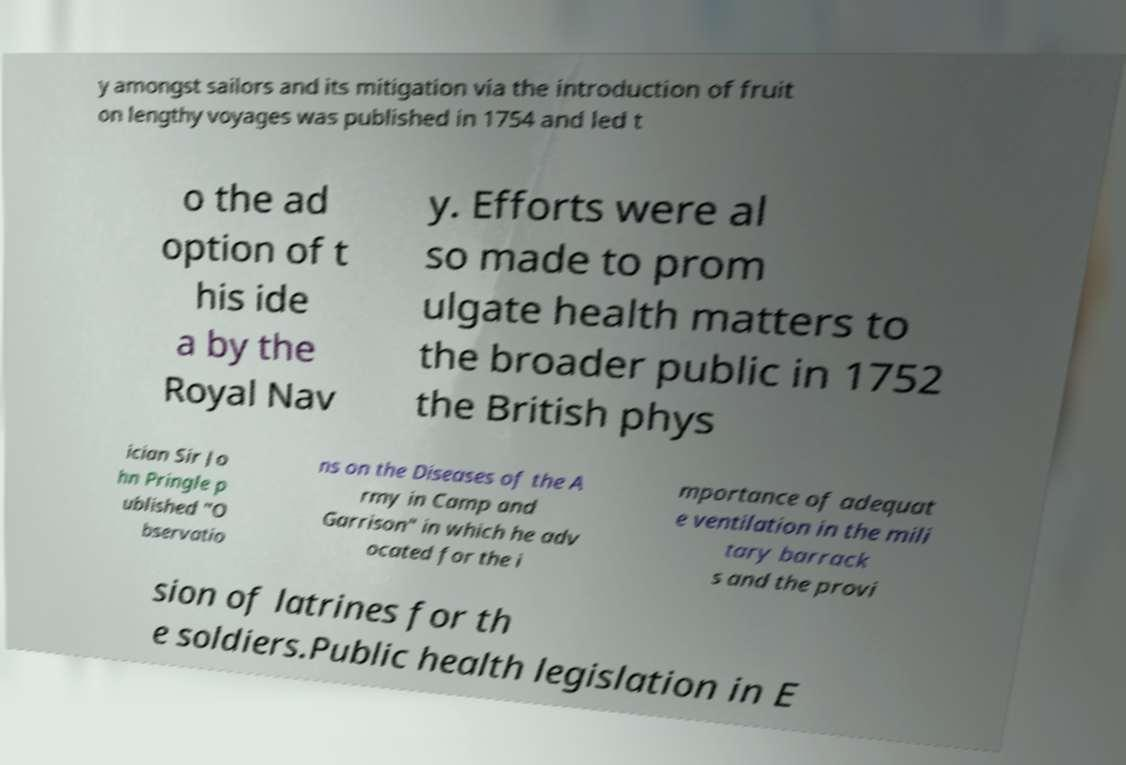Could you extract and type out the text from this image? y amongst sailors and its mitigation via the introduction of fruit on lengthy voyages was published in 1754 and led t o the ad option of t his ide a by the Royal Nav y. Efforts were al so made to prom ulgate health matters to the broader public in 1752 the British phys ician Sir Jo hn Pringle p ublished "O bservatio ns on the Diseases of the A rmy in Camp and Garrison" in which he adv ocated for the i mportance of adequat e ventilation in the mili tary barrack s and the provi sion of latrines for th e soldiers.Public health legislation in E 